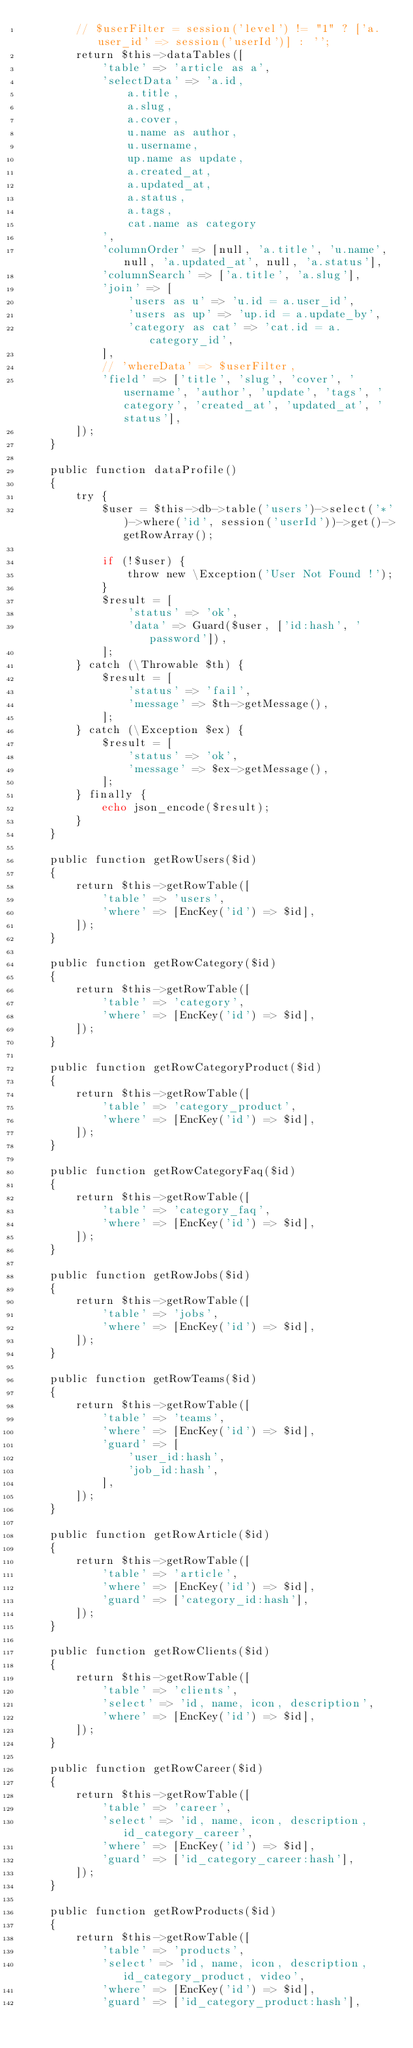Convert code to text. <code><loc_0><loc_0><loc_500><loc_500><_PHP_>        // $userFilter = session('level') != "1" ? ['a.user_id' => session('userId')] : '';
        return $this->dataTables([
            'table' => 'article as a',
            'selectData' => 'a.id,
                a.title, 
                a.slug, 
                a.cover, 
                u.name as author,
                u.username,
                up.name as update,
                a.created_at,
                a.updated_at,
                a.status,
                a.tags,
                cat.name as category
            ',
            'columnOrder' => [null, 'a.title', 'u.name', null, 'a.updated_at', null, 'a.status'],
            'columnSearch' => ['a.title', 'a.slug'],
            'join' => [
                'users as u' => 'u.id = a.user_id',
                'users as up' => 'up.id = a.update_by',
                'category as cat' => 'cat.id = a.category_id',
            ],
            // 'whereData' => $userFilter,
            'field' => ['title', 'slug', 'cover', 'username', 'author', 'update', 'tags', 'category', 'created_at', 'updated_at', 'status'],
        ]);
    }

    public function dataProfile()
    {
        try {
            $user = $this->db->table('users')->select('*')->where('id', session('userId'))->get()->getRowArray();

            if (!$user) {
                throw new \Exception('User Not Found !');
            }
            $result = [
                'status' => 'ok',
                'data' => Guard($user, ['id:hash', 'password']),
            ];
        } catch (\Throwable $th) {
            $result = [
                'status' => 'fail',
                'message' => $th->getMessage(),
            ];
        } catch (\Exception $ex) {
            $result = [
                'status' => 'ok',
                'message' => $ex->getMessage(),
            ];
        } finally {
            echo json_encode($result);
        }
    }

    public function getRowUsers($id)
    {
        return $this->getRowTable([
            'table' => 'users',
            'where' => [EncKey('id') => $id],
        ]);
    }

    public function getRowCategory($id)
    {
        return $this->getRowTable([
            'table' => 'category',
            'where' => [EncKey('id') => $id],
        ]);
    }

    public function getRowCategoryProduct($id)
    {
        return $this->getRowTable([
            'table' => 'category_product',
            'where' => [EncKey('id') => $id],
        ]);
    }

    public function getRowCategoryFaq($id)
    {
        return $this->getRowTable([
            'table' => 'category_faq',
            'where' => [EncKey('id') => $id],
        ]);
    }

    public function getRowJobs($id)
    {
        return $this->getRowTable([
            'table' => 'jobs',
            'where' => [EncKey('id') => $id],
        ]);
    }

    public function getRowTeams($id)
    {
        return $this->getRowTable([
            'table' => 'teams',
            'where' => [EncKey('id') => $id],
            'guard' => [
                'user_id:hash',
                'job_id:hash',
            ],
        ]);
    }

    public function getRowArticle($id)
    {
        return $this->getRowTable([
            'table' => 'article',
            'where' => [EncKey('id') => $id],
            'guard' => ['category_id:hash'],
        ]);
    }

    public function getRowClients($id)
    {
        return $this->getRowTable([
            'table' => 'clients',
            'select' => 'id, name, icon, description',
            'where' => [EncKey('id') => $id],
        ]);
    }

    public function getRowCareer($id)
    {
        return $this->getRowTable([
            'table' => 'career',
            'select' => 'id, name, icon, description, id_category_career',
            'where' => [EncKey('id') => $id],
            'guard' => ['id_category_career:hash'],
        ]);
    }

    public function getRowProducts($id)
    {
        return $this->getRowTable([
            'table' => 'products',
            'select' => 'id, name, icon, description, id_category_product, video',
            'where' => [EncKey('id') => $id],
            'guard' => ['id_category_product:hash'],</code> 